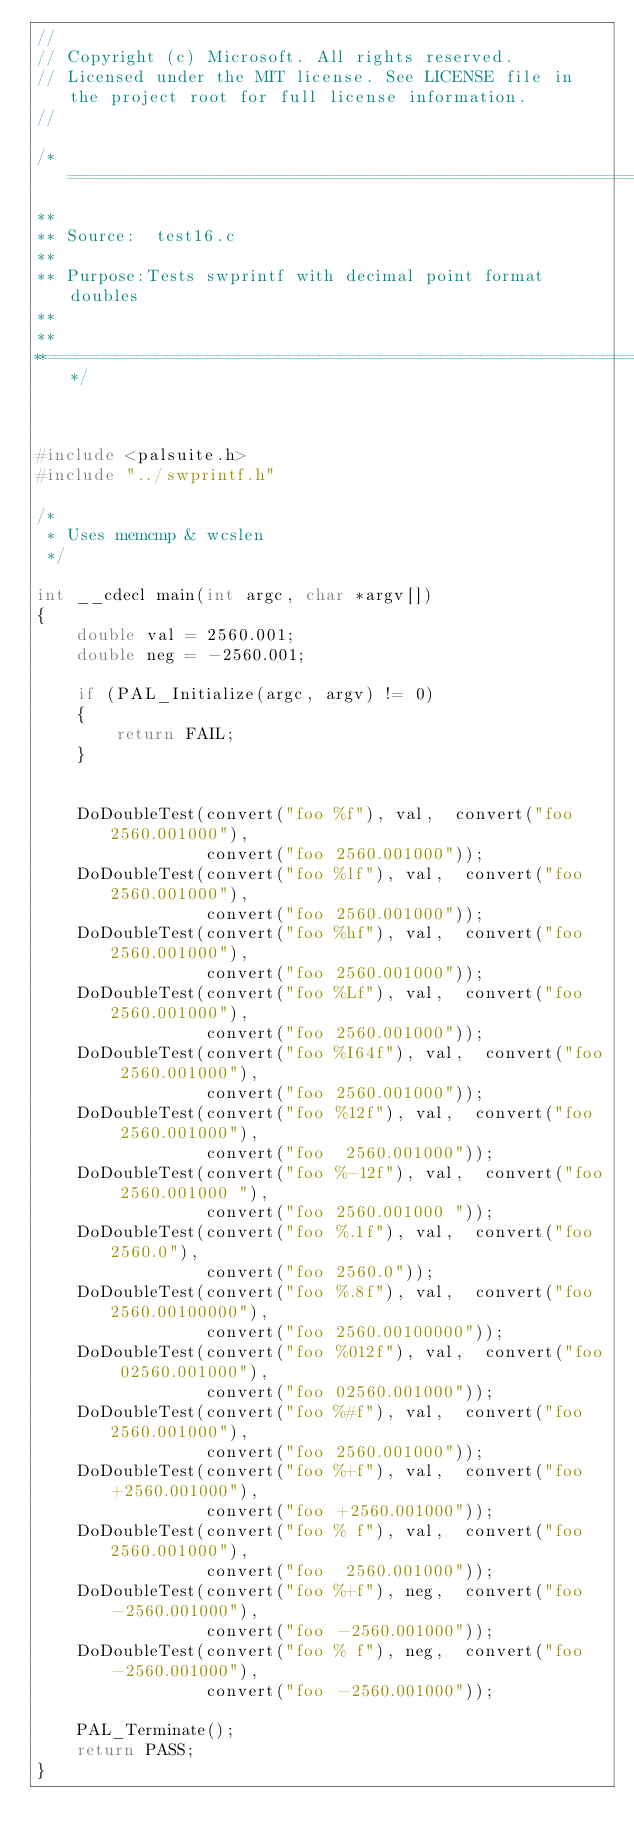Convert code to text. <code><loc_0><loc_0><loc_500><loc_500><_C_>//
// Copyright (c) Microsoft. All rights reserved.
// Licensed under the MIT license. See LICENSE file in the project root for full license information. 
//

/*============================================================================
**
** Source:  test16.c
**
** Purpose:Tests swprintf with decimal point format doubles 
**
**
**==========================================================================*/



#include <palsuite.h>
#include "../swprintf.h"

/*
 * Uses memcmp & wcslen
 */

int __cdecl main(int argc, char *argv[])
{
    double val = 2560.001;
    double neg = -2560.001;
    
    if (PAL_Initialize(argc, argv) != 0)
    {
        return FAIL;
    }


    DoDoubleTest(convert("foo %f"), val,  convert("foo 2560.001000"),
                 convert("foo 2560.001000"));
    DoDoubleTest(convert("foo %lf"), val,  convert("foo 2560.001000"),
                 convert("foo 2560.001000"));
    DoDoubleTest(convert("foo %hf"), val,  convert("foo 2560.001000"),
                 convert("foo 2560.001000"));
    DoDoubleTest(convert("foo %Lf"), val,  convert("foo 2560.001000"),
                 convert("foo 2560.001000"));
    DoDoubleTest(convert("foo %I64f"), val,  convert("foo 2560.001000"),
                 convert("foo 2560.001000"));
    DoDoubleTest(convert("foo %12f"), val,  convert("foo  2560.001000"),
                 convert("foo  2560.001000"));
    DoDoubleTest(convert("foo %-12f"), val,  convert("foo 2560.001000 "),
                 convert("foo 2560.001000 "));
    DoDoubleTest(convert("foo %.1f"), val,  convert("foo 2560.0"),
                 convert("foo 2560.0"));
    DoDoubleTest(convert("foo %.8f"), val,  convert("foo 2560.00100000"),
                 convert("foo 2560.00100000"));
    DoDoubleTest(convert("foo %012f"), val,  convert("foo 02560.001000"),
                 convert("foo 02560.001000"));
    DoDoubleTest(convert("foo %#f"), val,  convert("foo 2560.001000"),
                 convert("foo 2560.001000"));
    DoDoubleTest(convert("foo %+f"), val,  convert("foo +2560.001000"),
                 convert("foo +2560.001000"));
    DoDoubleTest(convert("foo % f"), val,  convert("foo  2560.001000"),
                 convert("foo  2560.001000"));
    DoDoubleTest(convert("foo %+f"), neg,  convert("foo -2560.001000"),
                 convert("foo -2560.001000"));
    DoDoubleTest(convert("foo % f"), neg,  convert("foo -2560.001000"),
                 convert("foo -2560.001000"));

    PAL_Terminate();
    return PASS;
}
</code> 